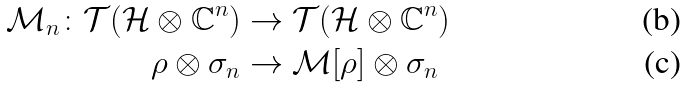Convert formula to latex. <formula><loc_0><loc_0><loc_500><loc_500>\mathcal { M } _ { n } \colon \mathcal { T } ( \mathcal { H } \otimes \mathbb { C } ^ { n } ) & \rightarrow \mathcal { T } ( \mathcal { H } \otimes \mathbb { C } ^ { n } ) \\ \rho \otimes \sigma _ { n } & \rightarrow \mathcal { M } [ \rho ] \otimes \sigma _ { n }</formula> 